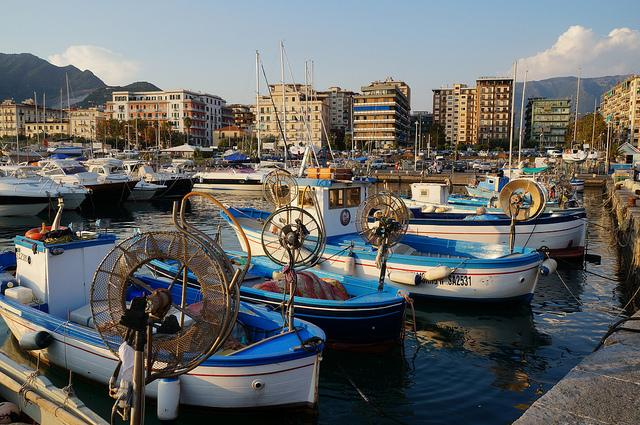What would this location be called?

Choices:
A) garage
B) dock
C) bunker
D) hangar dock 